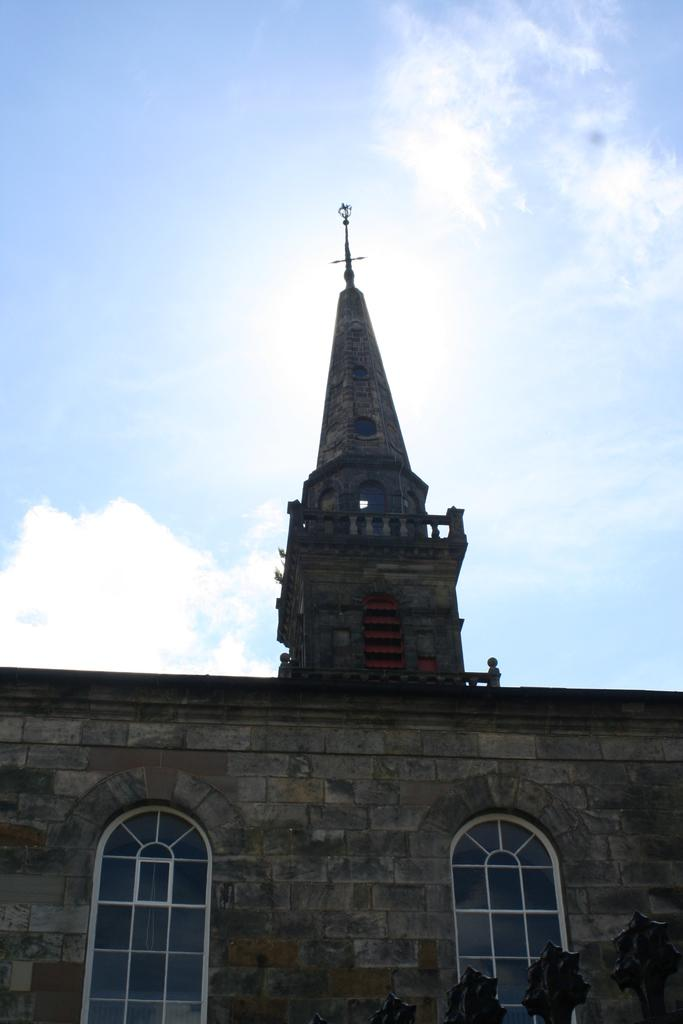What type of structure is in the image? There is a building in the image. What feature can be seen on the building? The building has glass windows. What can be seen in the background of the image? There is sky visible in the background of the image. What is present in the sky? Clouds are present in the sky. What type of plant is being used as a comb in the image? There is no plant or comb present in the image. 